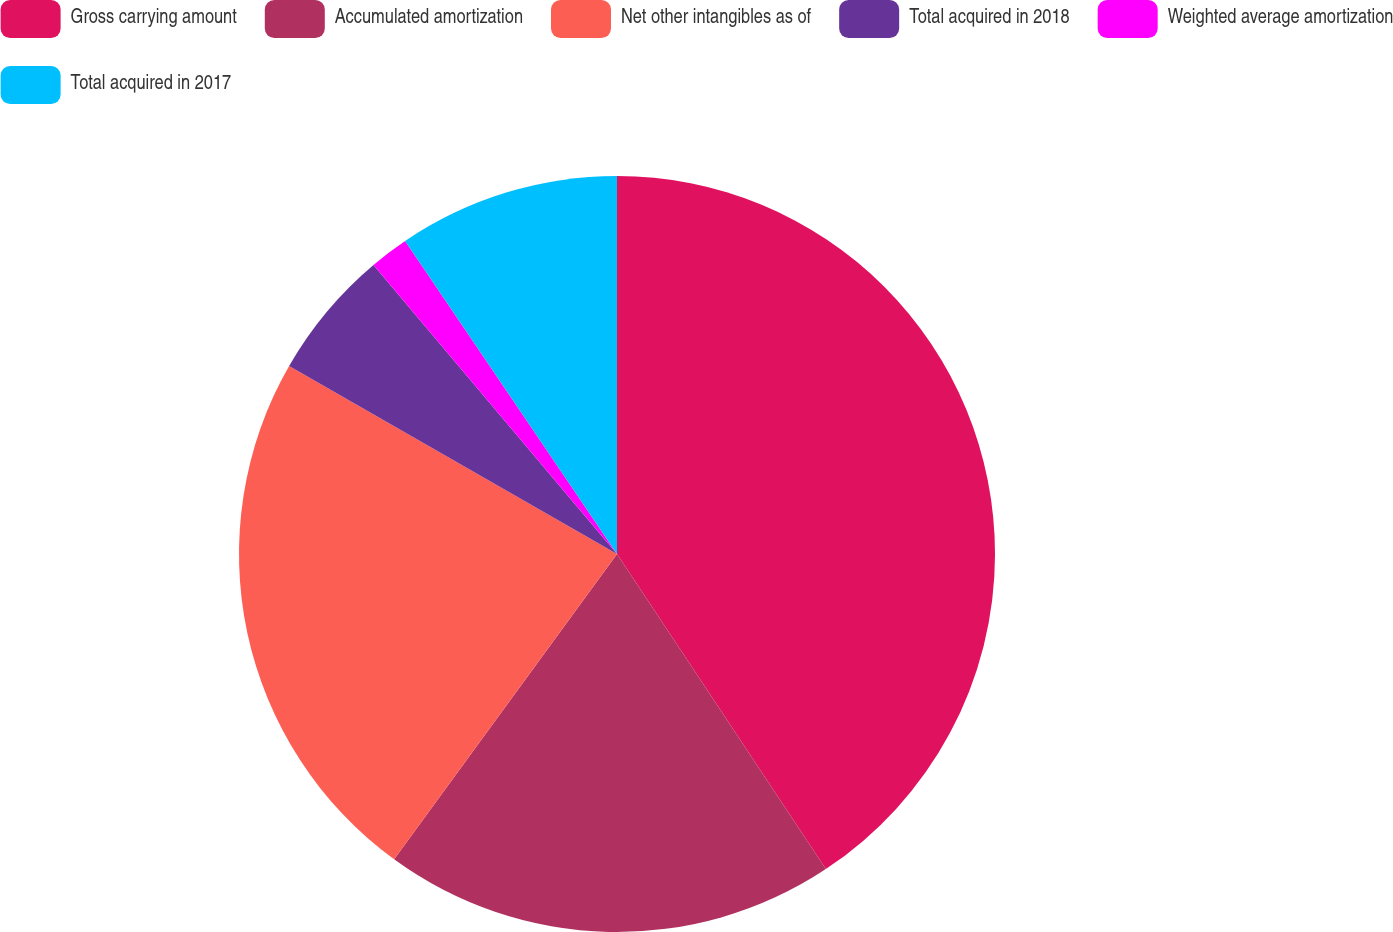Convert chart. <chart><loc_0><loc_0><loc_500><loc_500><pie_chart><fcel>Gross carrying amount<fcel>Accumulated amortization<fcel>Net other intangibles as of<fcel>Total acquired in 2018<fcel>Weighted average amortization<fcel>Total acquired in 2017<nl><fcel>40.68%<fcel>19.35%<fcel>23.25%<fcel>5.57%<fcel>1.67%<fcel>9.47%<nl></chart> 